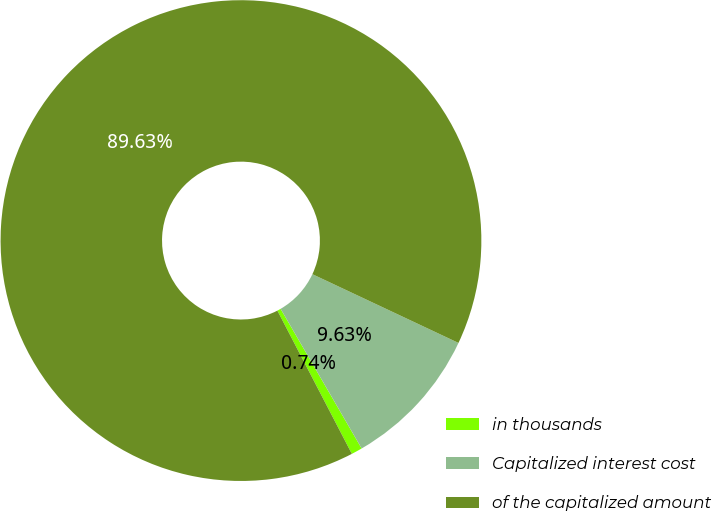Convert chart to OTSL. <chart><loc_0><loc_0><loc_500><loc_500><pie_chart><fcel>in thousands<fcel>Capitalized interest cost<fcel>of the capitalized amount<nl><fcel>0.74%<fcel>9.63%<fcel>89.64%<nl></chart> 